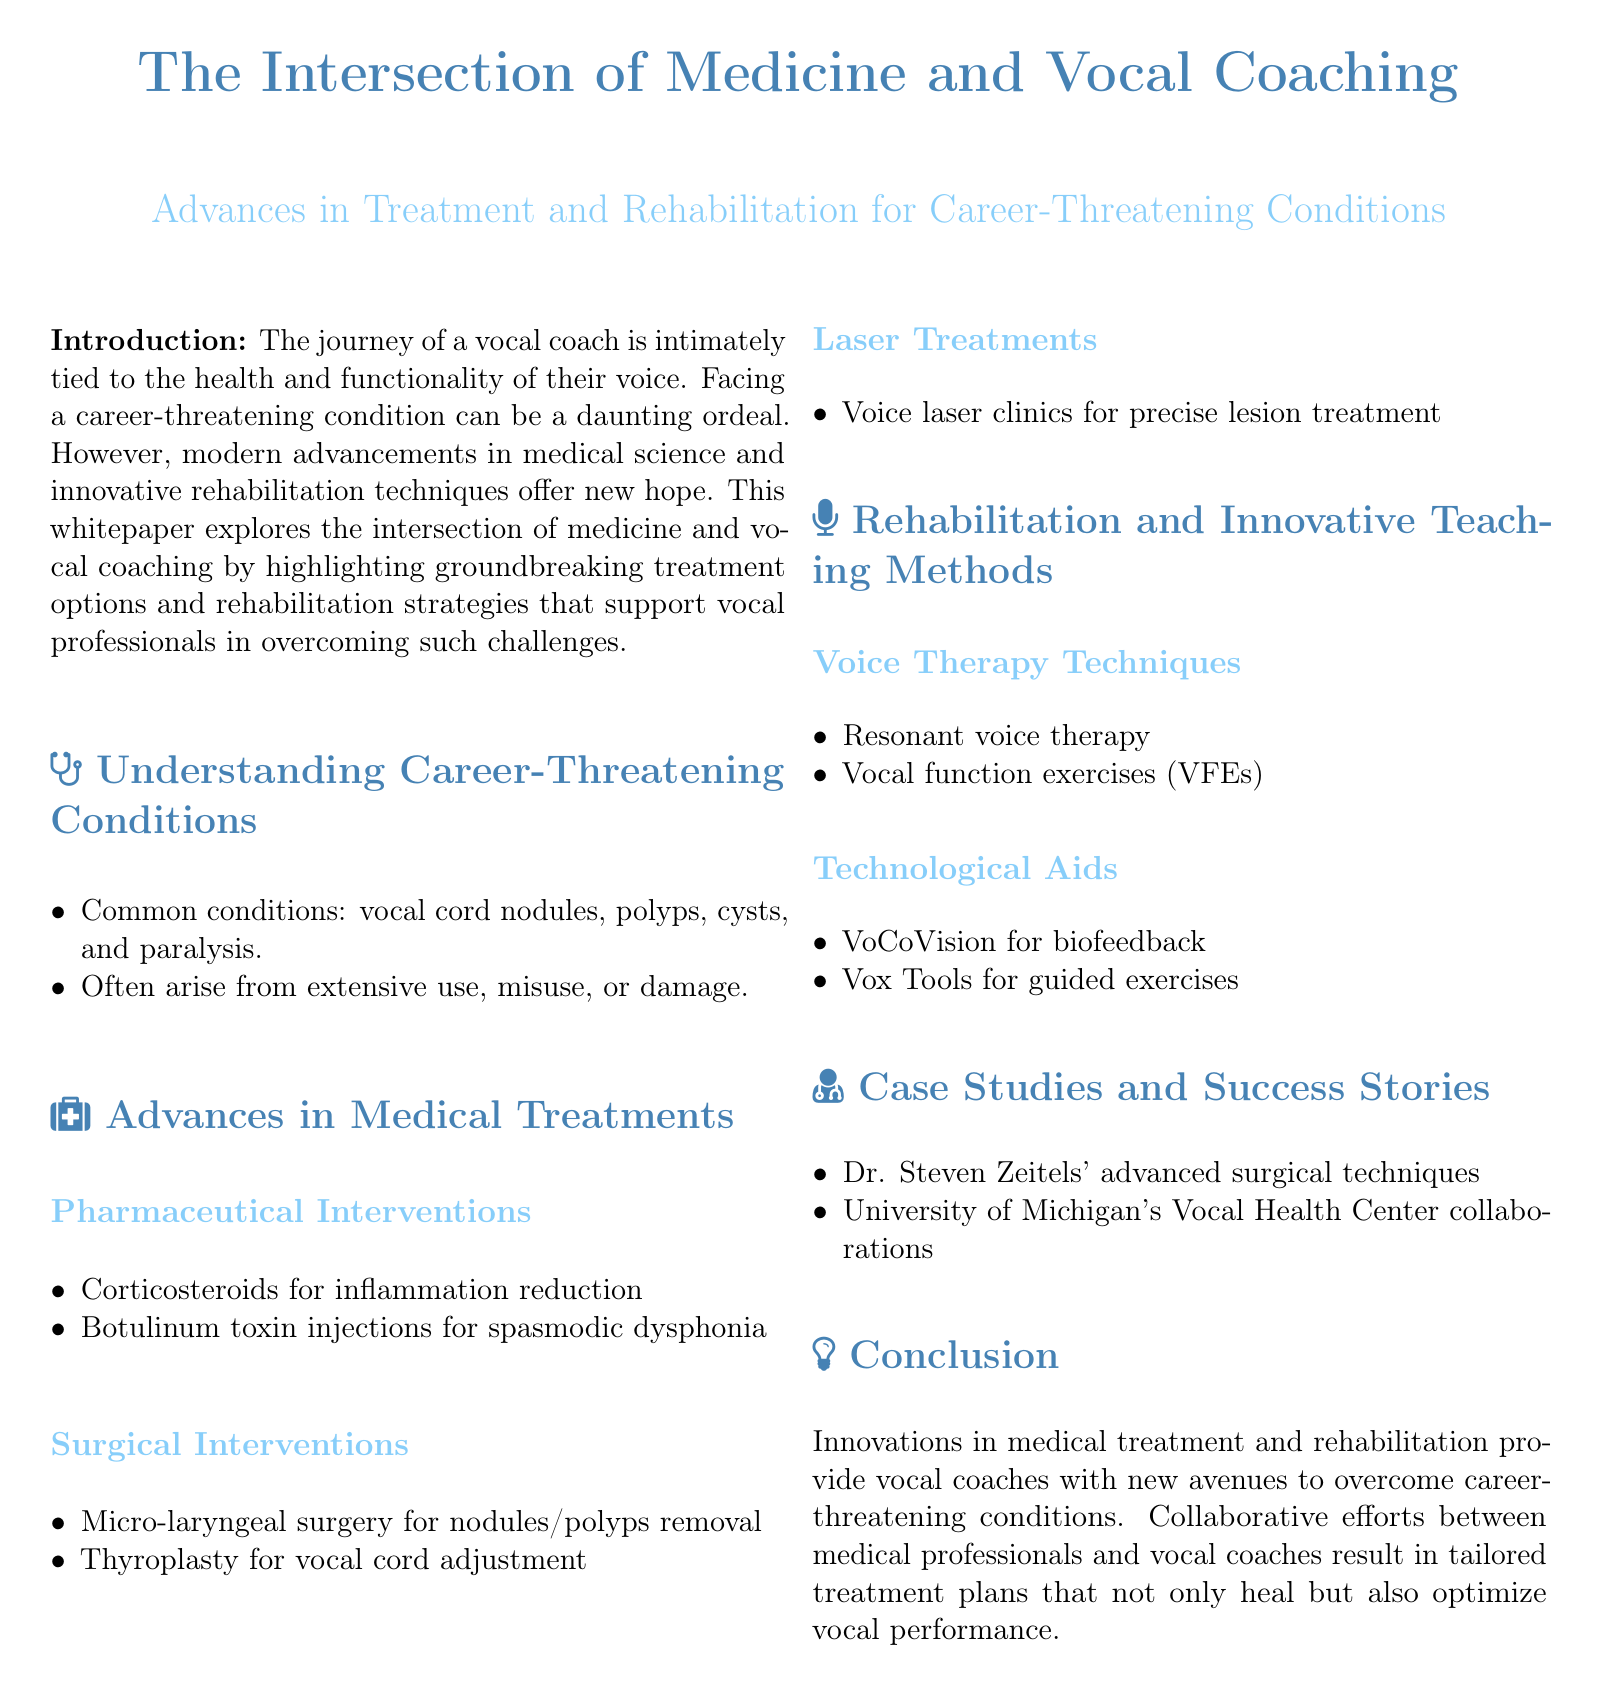What are common conditions faced by vocal coaches? The document lists common conditions that arise in vocal coaches, which include vocal cord nodules, polyps, cysts, and paralysis.
Answer: vocal cord nodules, polyps, cysts, and paralysis What is one pharmaceutical intervention mentioned? The document highlights corticosteroids as a pharmaceutical intervention for reducing inflammation in vocal conditions.
Answer: corticosteroids Which surgical procedure is used for vocal cord adjustment? The whitepaper mentions thyroplasty as a surgical intervention used for adjusting vocal cords.
Answer: thyroplasty What type of therapy technique is referred to for voice rehabilitation? Resonant voice therapy is one of the voice therapy techniques discussed in the document for rehabilitation.
Answer: Resonant voice therapy What is the purpose of VoCoVision in vocal coaching? VoCoVision is mentioned in the document as a technological aid used for biofeedback purposes in vocal rehabilitation.
Answer: biofeedback What kind of advanced techniques did Dr. Steven Zeitels develop? The document notes Dr. Steven Zeitels' contribution through advanced surgical techniques for vocal treatment.
Answer: advanced surgical techniques Which university is associated with vocal health collaborations? The University of Michigan is referenced in the document as being involved in collaborations at the Vocal Health Center.
Answer: University of Michigan What overall benefit do innovations in medical treatment provide to vocal coaches? The document discusses that innovations enable vocal coaches to overcome career-threatening conditions and optimize their vocal performance.
Answer: overcome career-threatening conditions and optimize vocal performance 